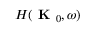Convert formula to latex. <formula><loc_0><loc_0><loc_500><loc_500>H ( K _ { 0 } , \omega )</formula> 